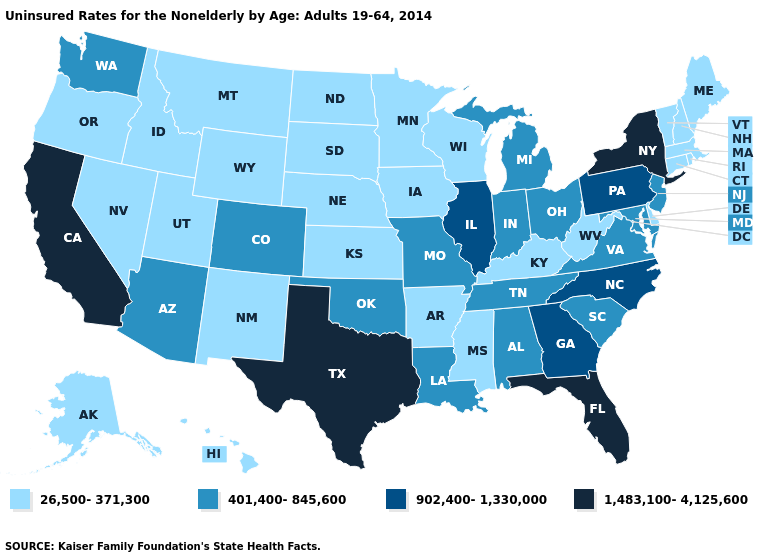Among the states that border New Jersey , which have the lowest value?
Quick response, please. Delaware. Does the map have missing data?
Keep it brief. No. Which states have the lowest value in the USA?
Concise answer only. Alaska, Arkansas, Connecticut, Delaware, Hawaii, Idaho, Iowa, Kansas, Kentucky, Maine, Massachusetts, Minnesota, Mississippi, Montana, Nebraska, Nevada, New Hampshire, New Mexico, North Dakota, Oregon, Rhode Island, South Dakota, Utah, Vermont, West Virginia, Wisconsin, Wyoming. Does the map have missing data?
Write a very short answer. No. Which states hav the highest value in the West?
Be succinct. California. Does the first symbol in the legend represent the smallest category?
Keep it brief. Yes. What is the value of New Hampshire?
Concise answer only. 26,500-371,300. Name the states that have a value in the range 902,400-1,330,000?
Keep it brief. Georgia, Illinois, North Carolina, Pennsylvania. What is the highest value in the USA?
Short answer required. 1,483,100-4,125,600. Does Kentucky have a lower value than Virginia?
Short answer required. Yes. What is the value of New Mexico?
Concise answer only. 26,500-371,300. Does Iowa have the same value as Nebraska?
Answer briefly. Yes. Is the legend a continuous bar?
Answer briefly. No. Among the states that border New York , does Connecticut have the lowest value?
Concise answer only. Yes. 